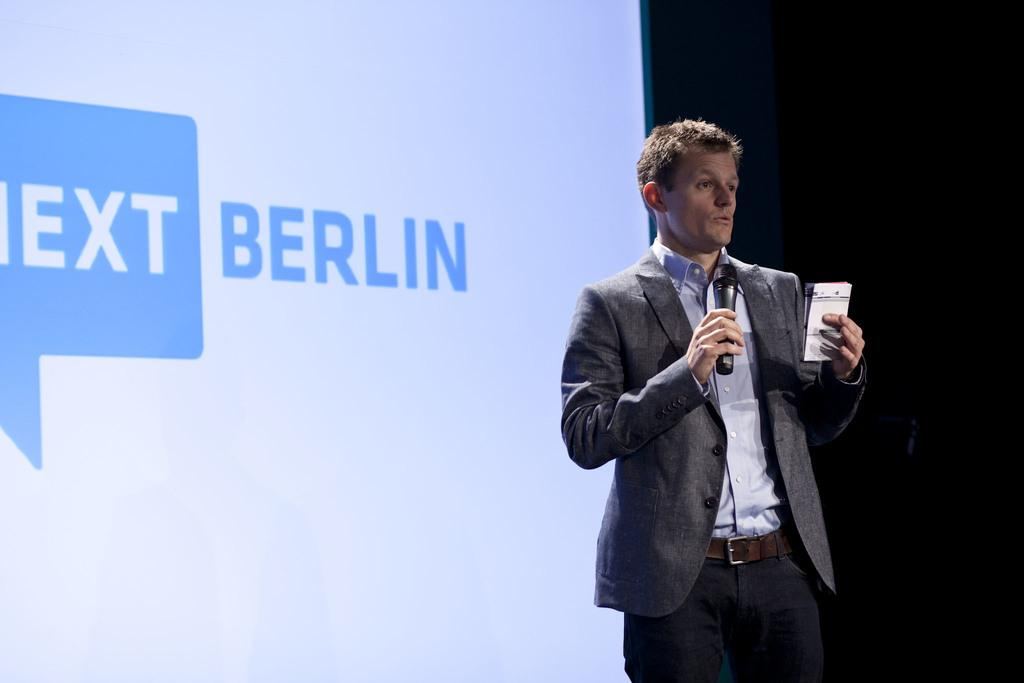What is in the background of the image? There is a screen in the background of the image. What is the man in the image doing? The man is standing in the image and holding a microphone in his hand. What is the man saying or communicating? The man is talking. What type of girl is holding a tray in the image? There is no girl or tray present in the image. What is the cause of the man's speech in the image? The facts provided do not give any information about the cause or reason for the man's speech in the image. 